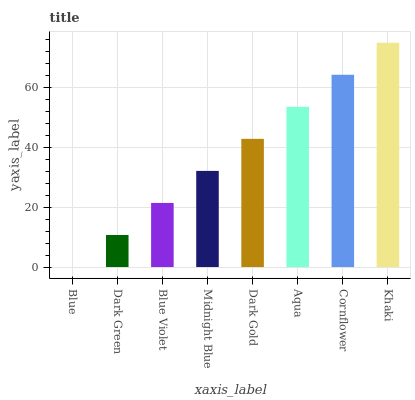Is Blue the minimum?
Answer yes or no. Yes. Is Khaki the maximum?
Answer yes or no. Yes. Is Dark Green the minimum?
Answer yes or no. No. Is Dark Green the maximum?
Answer yes or no. No. Is Dark Green greater than Blue?
Answer yes or no. Yes. Is Blue less than Dark Green?
Answer yes or no. Yes. Is Blue greater than Dark Green?
Answer yes or no. No. Is Dark Green less than Blue?
Answer yes or no. No. Is Dark Gold the high median?
Answer yes or no. Yes. Is Midnight Blue the low median?
Answer yes or no. Yes. Is Dark Green the high median?
Answer yes or no. No. Is Cornflower the low median?
Answer yes or no. No. 